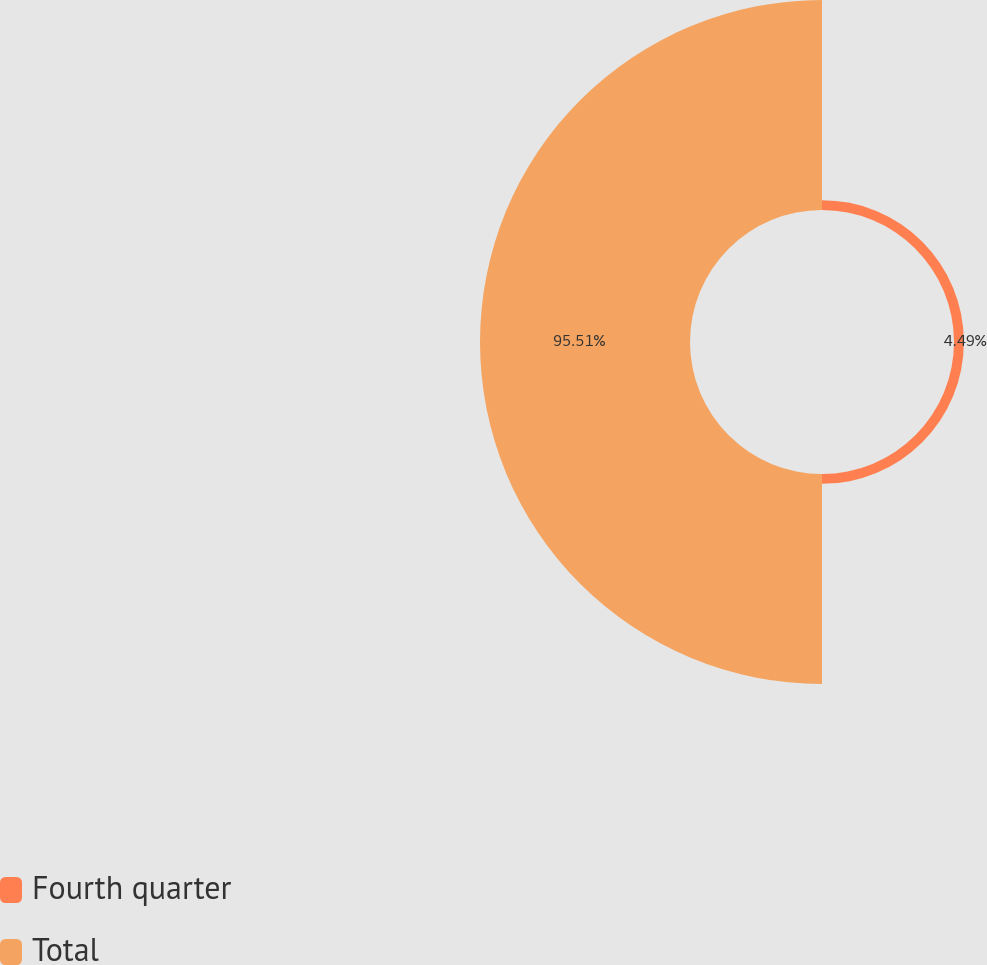Convert chart. <chart><loc_0><loc_0><loc_500><loc_500><pie_chart><fcel>Fourth quarter<fcel>Total<nl><fcel>4.49%<fcel>95.51%<nl></chart> 